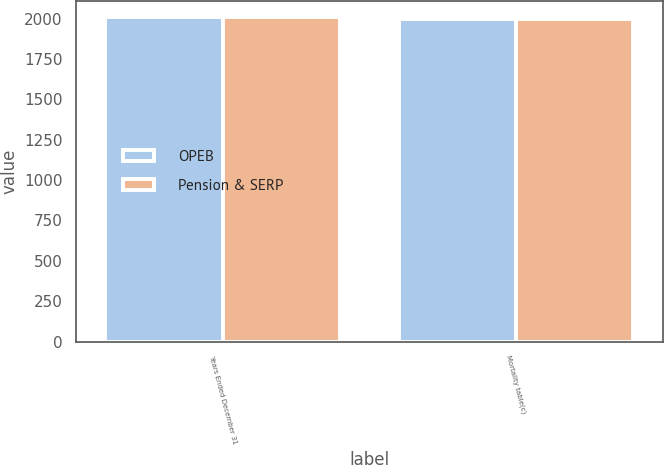Convert chart. <chart><loc_0><loc_0><loc_500><loc_500><stacked_bar_chart><ecel><fcel>Years Ended December 31<fcel>Mortality table(c)<nl><fcel>OPEB<fcel>2007<fcel>2000<nl><fcel>Pension & SERP<fcel>2007<fcel>2000<nl></chart> 